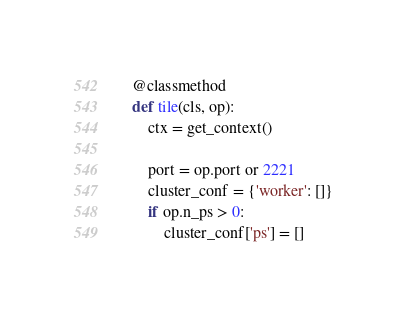Convert code to text. <code><loc_0><loc_0><loc_500><loc_500><_Python_>
    @classmethod
    def tile(cls, op):
        ctx = get_context()

        port = op.port or 2221
        cluster_conf = {'worker': []}
        if op.n_ps > 0:
            cluster_conf['ps'] = []</code> 